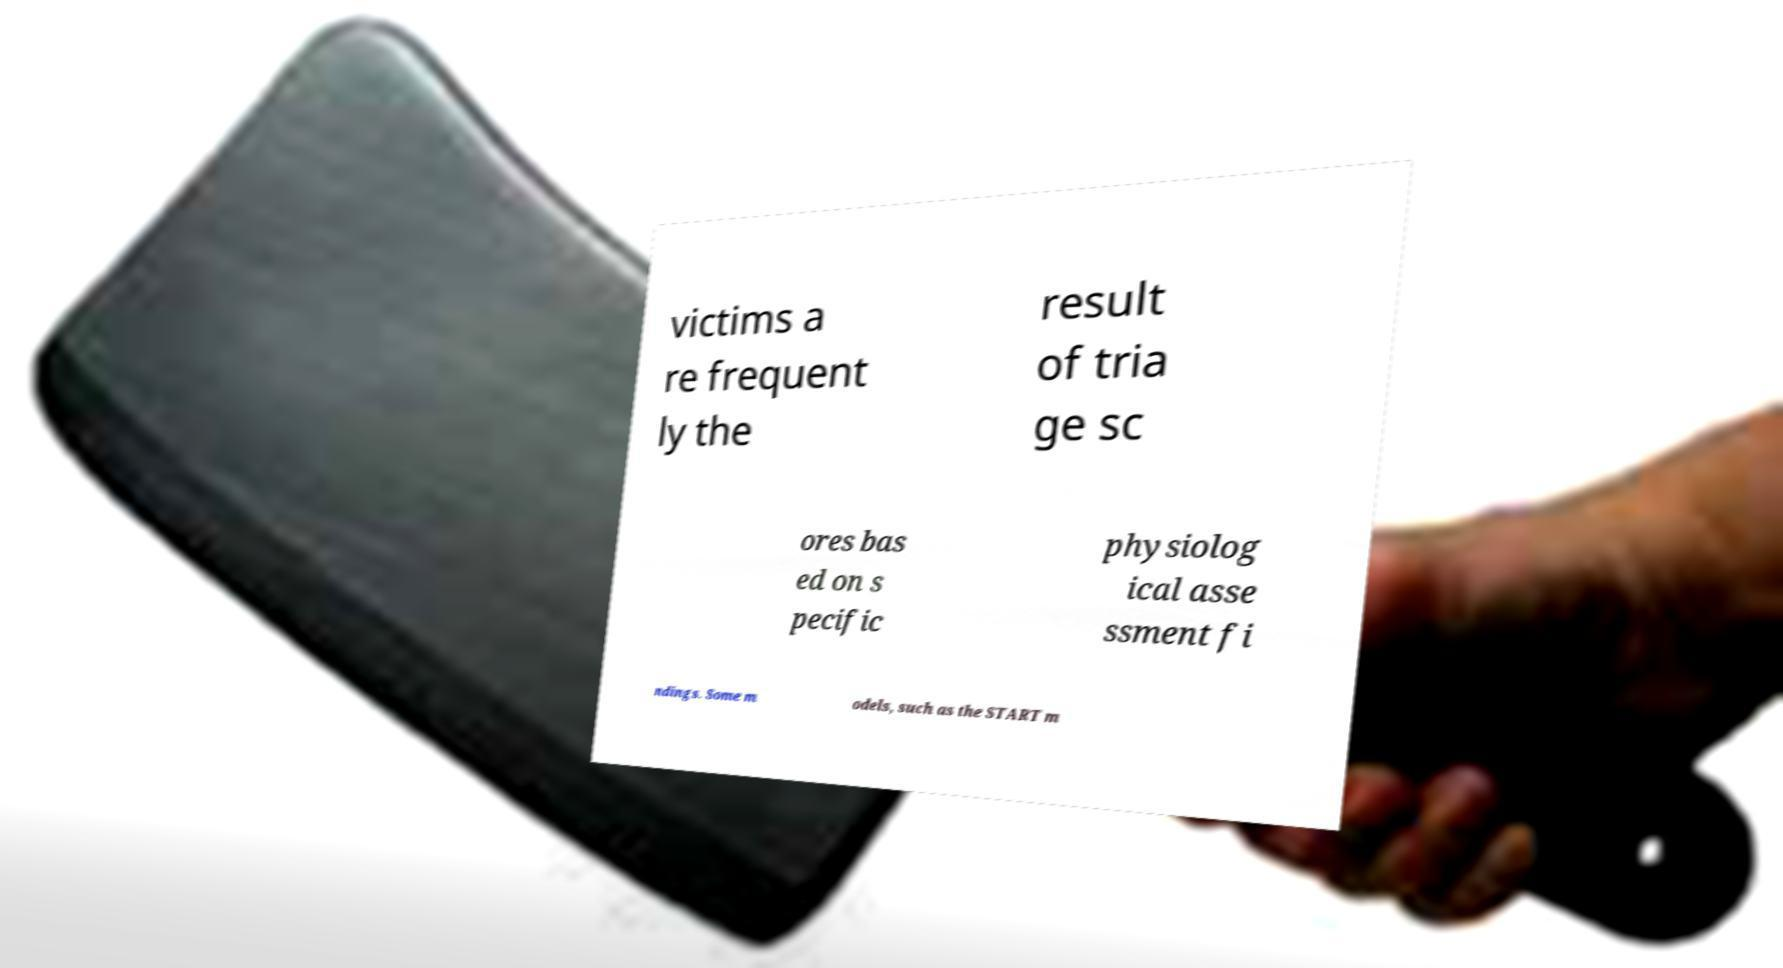For documentation purposes, I need the text within this image transcribed. Could you provide that? victims a re frequent ly the result of tria ge sc ores bas ed on s pecific physiolog ical asse ssment fi ndings. Some m odels, such as the START m 